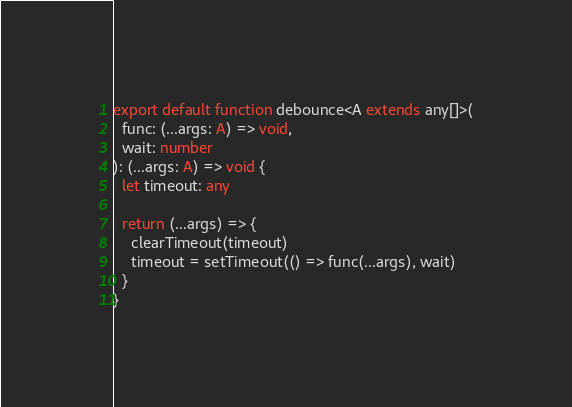<code> <loc_0><loc_0><loc_500><loc_500><_TypeScript_>export default function debounce<A extends any[]>(
  func: (...args: A) => void,
  wait: number
): (...args: A) => void {
  let timeout: any

  return (...args) => {
    clearTimeout(timeout)
    timeout = setTimeout(() => func(...args), wait)
  }
}
</code> 